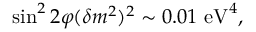Convert formula to latex. <formula><loc_0><loc_0><loc_500><loc_500>\sin ^ { 2 } 2 \varphi ( \delta m ^ { 2 } ) ^ { 2 } \sim 0 . 0 1 e V ^ { 4 } ,</formula> 